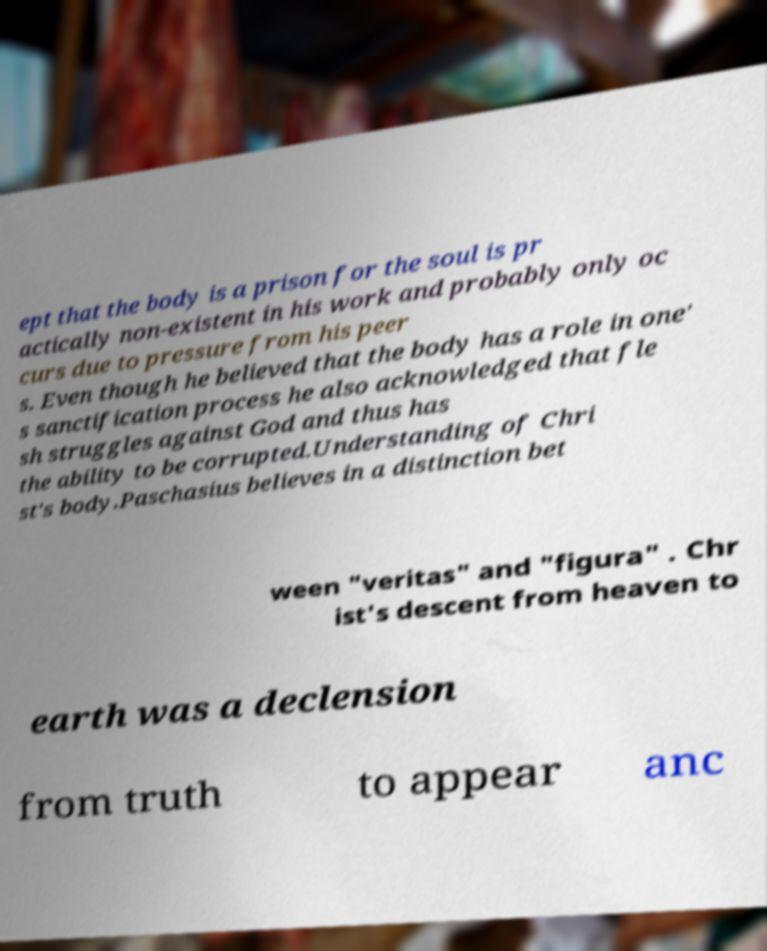For documentation purposes, I need the text within this image transcribed. Could you provide that? ept that the body is a prison for the soul is pr actically non-existent in his work and probably only oc curs due to pressure from his peer s. Even though he believed that the body has a role in one' s sanctification process he also acknowledged that fle sh struggles against God and thus has the ability to be corrupted.Understanding of Chri st's body.Paschasius believes in a distinction bet ween "veritas" and "figura" . Chr ist's descent from heaven to earth was a declension from truth to appear anc 